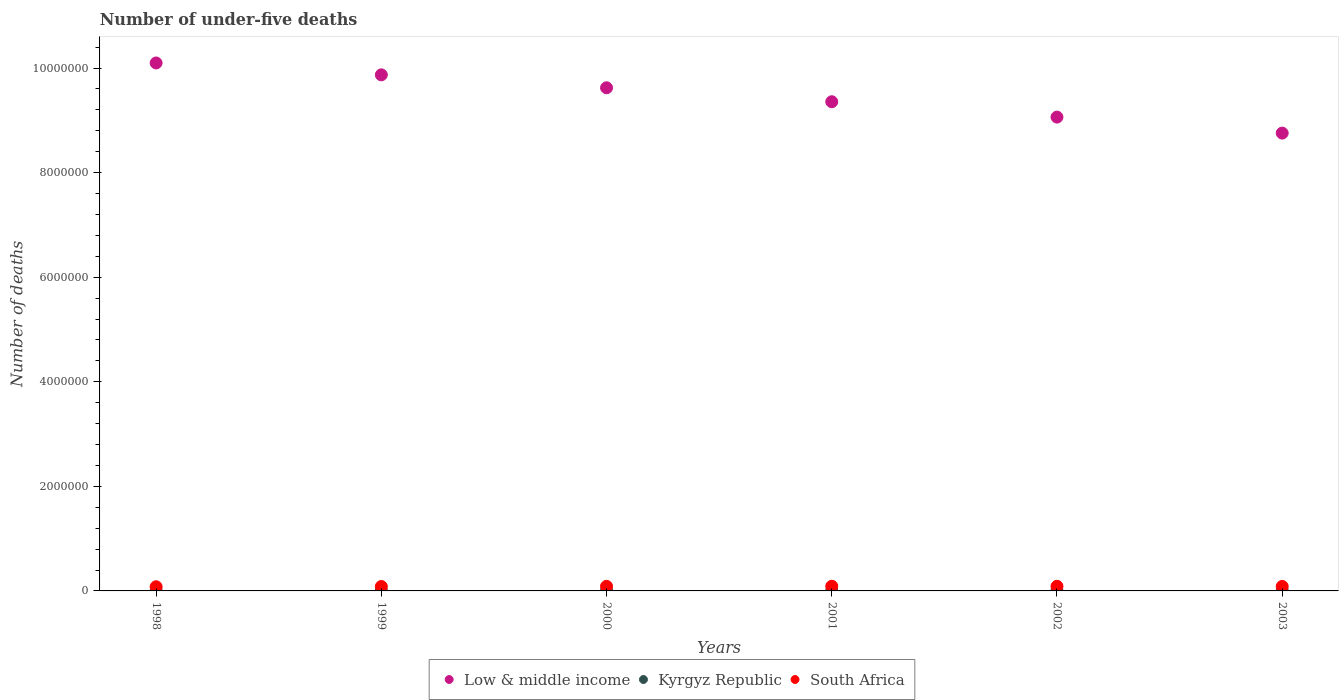How many different coloured dotlines are there?
Offer a very short reply. 3. Is the number of dotlines equal to the number of legend labels?
Your response must be concise. Yes. What is the number of under-five deaths in Low & middle income in 2000?
Ensure brevity in your answer.  9.62e+06. Across all years, what is the maximum number of under-five deaths in Low & middle income?
Offer a terse response. 1.01e+07. Across all years, what is the minimum number of under-five deaths in South Africa?
Make the answer very short. 7.96e+04. What is the total number of under-five deaths in South Africa in the graph?
Provide a short and direct response. 5.15e+05. What is the difference between the number of under-five deaths in South Africa in 1998 and that in 1999?
Ensure brevity in your answer.  -4712. What is the difference between the number of under-five deaths in Kyrgyz Republic in 1998 and the number of under-five deaths in South Africa in 2000?
Your answer should be very brief. -8.18e+04. What is the average number of under-five deaths in Kyrgyz Republic per year?
Your answer should be compact. 5219. In the year 1999, what is the difference between the number of under-five deaths in Kyrgyz Republic and number of under-five deaths in South Africa?
Your answer should be very brief. -7.86e+04. In how many years, is the number of under-five deaths in South Africa greater than 8000000?
Give a very brief answer. 0. What is the ratio of the number of under-five deaths in Low & middle income in 1999 to that in 2000?
Your response must be concise. 1.03. Is the number of under-five deaths in South Africa in 1999 less than that in 2000?
Keep it short and to the point. Yes. What is the difference between the highest and the second highest number of under-five deaths in South Africa?
Provide a succinct answer. 893. What is the difference between the highest and the lowest number of under-five deaths in South Africa?
Your answer should be compact. 9711. In how many years, is the number of under-five deaths in Low & middle income greater than the average number of under-five deaths in Low & middle income taken over all years?
Provide a succinct answer. 3. Is it the case that in every year, the sum of the number of under-five deaths in Kyrgyz Republic and number of under-five deaths in Low & middle income  is greater than the number of under-five deaths in South Africa?
Your answer should be very brief. Yes. How many dotlines are there?
Offer a terse response. 3. What is the difference between two consecutive major ticks on the Y-axis?
Your answer should be very brief. 2.00e+06. Does the graph contain any zero values?
Your answer should be compact. No. Does the graph contain grids?
Give a very brief answer. No. Where does the legend appear in the graph?
Ensure brevity in your answer.  Bottom center. How many legend labels are there?
Provide a succinct answer. 3. How are the legend labels stacked?
Make the answer very short. Horizontal. What is the title of the graph?
Offer a very short reply. Number of under-five deaths. Does "Mexico" appear as one of the legend labels in the graph?
Offer a terse response. No. What is the label or title of the Y-axis?
Provide a short and direct response. Number of deaths. What is the Number of deaths of Low & middle income in 1998?
Provide a succinct answer. 1.01e+07. What is the Number of deaths of Kyrgyz Republic in 1998?
Provide a succinct answer. 6098. What is the Number of deaths in South Africa in 1998?
Provide a succinct answer. 7.96e+04. What is the Number of deaths of Low & middle income in 1999?
Your response must be concise. 9.87e+06. What is the Number of deaths in Kyrgyz Republic in 1999?
Ensure brevity in your answer.  5741. What is the Number of deaths of South Africa in 1999?
Your answer should be compact. 8.43e+04. What is the Number of deaths in Low & middle income in 2000?
Your answer should be very brief. 9.62e+06. What is the Number of deaths of Kyrgyz Republic in 2000?
Make the answer very short. 5380. What is the Number of deaths in South Africa in 2000?
Provide a short and direct response. 8.79e+04. What is the Number of deaths of Low & middle income in 2001?
Give a very brief answer. 9.36e+06. What is the Number of deaths in Kyrgyz Republic in 2001?
Keep it short and to the point. 5021. What is the Number of deaths in South Africa in 2001?
Make the answer very short. 8.93e+04. What is the Number of deaths in Low & middle income in 2002?
Offer a terse response. 9.06e+06. What is the Number of deaths in Kyrgyz Republic in 2002?
Your answer should be compact. 4685. What is the Number of deaths in South Africa in 2002?
Your response must be concise. 8.84e+04. What is the Number of deaths in Low & middle income in 2003?
Provide a short and direct response. 8.76e+06. What is the Number of deaths in Kyrgyz Republic in 2003?
Offer a very short reply. 4389. What is the Number of deaths in South Africa in 2003?
Provide a short and direct response. 8.58e+04. Across all years, what is the maximum Number of deaths of Low & middle income?
Keep it short and to the point. 1.01e+07. Across all years, what is the maximum Number of deaths of Kyrgyz Republic?
Make the answer very short. 6098. Across all years, what is the maximum Number of deaths of South Africa?
Your answer should be very brief. 8.93e+04. Across all years, what is the minimum Number of deaths in Low & middle income?
Offer a terse response. 8.76e+06. Across all years, what is the minimum Number of deaths in Kyrgyz Republic?
Offer a very short reply. 4389. Across all years, what is the minimum Number of deaths in South Africa?
Ensure brevity in your answer.  7.96e+04. What is the total Number of deaths of Low & middle income in the graph?
Provide a short and direct response. 5.68e+07. What is the total Number of deaths in Kyrgyz Republic in the graph?
Your response must be concise. 3.13e+04. What is the total Number of deaths of South Africa in the graph?
Offer a terse response. 5.15e+05. What is the difference between the Number of deaths of Low & middle income in 1998 and that in 1999?
Your answer should be very brief. 2.27e+05. What is the difference between the Number of deaths in Kyrgyz Republic in 1998 and that in 1999?
Offer a terse response. 357. What is the difference between the Number of deaths of South Africa in 1998 and that in 1999?
Give a very brief answer. -4712. What is the difference between the Number of deaths of Low & middle income in 1998 and that in 2000?
Give a very brief answer. 4.75e+05. What is the difference between the Number of deaths of Kyrgyz Republic in 1998 and that in 2000?
Your answer should be very brief. 718. What is the difference between the Number of deaths of South Africa in 1998 and that in 2000?
Keep it short and to the point. -8266. What is the difference between the Number of deaths of Low & middle income in 1998 and that in 2001?
Provide a short and direct response. 7.42e+05. What is the difference between the Number of deaths in Kyrgyz Republic in 1998 and that in 2001?
Your answer should be compact. 1077. What is the difference between the Number of deaths of South Africa in 1998 and that in 2001?
Offer a terse response. -9711. What is the difference between the Number of deaths of Low & middle income in 1998 and that in 2002?
Your response must be concise. 1.04e+06. What is the difference between the Number of deaths of Kyrgyz Republic in 1998 and that in 2002?
Make the answer very short. 1413. What is the difference between the Number of deaths in South Africa in 1998 and that in 2002?
Your response must be concise. -8818. What is the difference between the Number of deaths in Low & middle income in 1998 and that in 2003?
Make the answer very short. 1.34e+06. What is the difference between the Number of deaths of Kyrgyz Republic in 1998 and that in 2003?
Keep it short and to the point. 1709. What is the difference between the Number of deaths of South Africa in 1998 and that in 2003?
Ensure brevity in your answer.  -6147. What is the difference between the Number of deaths in Low & middle income in 1999 and that in 2000?
Offer a terse response. 2.48e+05. What is the difference between the Number of deaths of Kyrgyz Republic in 1999 and that in 2000?
Give a very brief answer. 361. What is the difference between the Number of deaths in South Africa in 1999 and that in 2000?
Keep it short and to the point. -3554. What is the difference between the Number of deaths in Low & middle income in 1999 and that in 2001?
Offer a terse response. 5.14e+05. What is the difference between the Number of deaths of Kyrgyz Republic in 1999 and that in 2001?
Provide a succinct answer. 720. What is the difference between the Number of deaths of South Africa in 1999 and that in 2001?
Give a very brief answer. -4999. What is the difference between the Number of deaths in Low & middle income in 1999 and that in 2002?
Your response must be concise. 8.08e+05. What is the difference between the Number of deaths of Kyrgyz Republic in 1999 and that in 2002?
Your answer should be very brief. 1056. What is the difference between the Number of deaths in South Africa in 1999 and that in 2002?
Provide a succinct answer. -4106. What is the difference between the Number of deaths of Low & middle income in 1999 and that in 2003?
Your answer should be very brief. 1.11e+06. What is the difference between the Number of deaths in Kyrgyz Republic in 1999 and that in 2003?
Your response must be concise. 1352. What is the difference between the Number of deaths in South Africa in 1999 and that in 2003?
Provide a succinct answer. -1435. What is the difference between the Number of deaths of Low & middle income in 2000 and that in 2001?
Make the answer very short. 2.67e+05. What is the difference between the Number of deaths in Kyrgyz Republic in 2000 and that in 2001?
Your answer should be very brief. 359. What is the difference between the Number of deaths of South Africa in 2000 and that in 2001?
Keep it short and to the point. -1445. What is the difference between the Number of deaths in Low & middle income in 2000 and that in 2002?
Offer a very short reply. 5.61e+05. What is the difference between the Number of deaths of Kyrgyz Republic in 2000 and that in 2002?
Make the answer very short. 695. What is the difference between the Number of deaths of South Africa in 2000 and that in 2002?
Provide a succinct answer. -552. What is the difference between the Number of deaths in Low & middle income in 2000 and that in 2003?
Your answer should be compact. 8.67e+05. What is the difference between the Number of deaths in Kyrgyz Republic in 2000 and that in 2003?
Offer a very short reply. 991. What is the difference between the Number of deaths of South Africa in 2000 and that in 2003?
Offer a very short reply. 2119. What is the difference between the Number of deaths in Low & middle income in 2001 and that in 2002?
Give a very brief answer. 2.94e+05. What is the difference between the Number of deaths in Kyrgyz Republic in 2001 and that in 2002?
Provide a short and direct response. 336. What is the difference between the Number of deaths of South Africa in 2001 and that in 2002?
Make the answer very short. 893. What is the difference between the Number of deaths of Low & middle income in 2001 and that in 2003?
Offer a very short reply. 6.00e+05. What is the difference between the Number of deaths in Kyrgyz Republic in 2001 and that in 2003?
Provide a short and direct response. 632. What is the difference between the Number of deaths in South Africa in 2001 and that in 2003?
Give a very brief answer. 3564. What is the difference between the Number of deaths of Low & middle income in 2002 and that in 2003?
Provide a succinct answer. 3.06e+05. What is the difference between the Number of deaths of Kyrgyz Republic in 2002 and that in 2003?
Ensure brevity in your answer.  296. What is the difference between the Number of deaths in South Africa in 2002 and that in 2003?
Give a very brief answer. 2671. What is the difference between the Number of deaths in Low & middle income in 1998 and the Number of deaths in Kyrgyz Republic in 1999?
Your response must be concise. 1.01e+07. What is the difference between the Number of deaths in Low & middle income in 1998 and the Number of deaths in South Africa in 1999?
Provide a short and direct response. 1.00e+07. What is the difference between the Number of deaths of Kyrgyz Republic in 1998 and the Number of deaths of South Africa in 1999?
Provide a succinct answer. -7.82e+04. What is the difference between the Number of deaths of Low & middle income in 1998 and the Number of deaths of Kyrgyz Republic in 2000?
Your response must be concise. 1.01e+07. What is the difference between the Number of deaths of Low & middle income in 1998 and the Number of deaths of South Africa in 2000?
Give a very brief answer. 1.00e+07. What is the difference between the Number of deaths of Kyrgyz Republic in 1998 and the Number of deaths of South Africa in 2000?
Keep it short and to the point. -8.18e+04. What is the difference between the Number of deaths in Low & middle income in 1998 and the Number of deaths in Kyrgyz Republic in 2001?
Offer a terse response. 1.01e+07. What is the difference between the Number of deaths in Low & middle income in 1998 and the Number of deaths in South Africa in 2001?
Offer a terse response. 1.00e+07. What is the difference between the Number of deaths in Kyrgyz Republic in 1998 and the Number of deaths in South Africa in 2001?
Your answer should be very brief. -8.32e+04. What is the difference between the Number of deaths of Low & middle income in 1998 and the Number of deaths of Kyrgyz Republic in 2002?
Offer a very short reply. 1.01e+07. What is the difference between the Number of deaths in Low & middle income in 1998 and the Number of deaths in South Africa in 2002?
Provide a short and direct response. 1.00e+07. What is the difference between the Number of deaths in Kyrgyz Republic in 1998 and the Number of deaths in South Africa in 2002?
Offer a terse response. -8.23e+04. What is the difference between the Number of deaths of Low & middle income in 1998 and the Number of deaths of Kyrgyz Republic in 2003?
Your response must be concise. 1.01e+07. What is the difference between the Number of deaths in Low & middle income in 1998 and the Number of deaths in South Africa in 2003?
Provide a short and direct response. 1.00e+07. What is the difference between the Number of deaths of Kyrgyz Republic in 1998 and the Number of deaths of South Africa in 2003?
Ensure brevity in your answer.  -7.97e+04. What is the difference between the Number of deaths in Low & middle income in 1999 and the Number of deaths in Kyrgyz Republic in 2000?
Your answer should be compact. 9.87e+06. What is the difference between the Number of deaths of Low & middle income in 1999 and the Number of deaths of South Africa in 2000?
Make the answer very short. 9.78e+06. What is the difference between the Number of deaths in Kyrgyz Republic in 1999 and the Number of deaths in South Africa in 2000?
Make the answer very short. -8.21e+04. What is the difference between the Number of deaths in Low & middle income in 1999 and the Number of deaths in Kyrgyz Republic in 2001?
Provide a succinct answer. 9.87e+06. What is the difference between the Number of deaths in Low & middle income in 1999 and the Number of deaths in South Africa in 2001?
Ensure brevity in your answer.  9.78e+06. What is the difference between the Number of deaths of Kyrgyz Republic in 1999 and the Number of deaths of South Africa in 2001?
Give a very brief answer. -8.36e+04. What is the difference between the Number of deaths in Low & middle income in 1999 and the Number of deaths in Kyrgyz Republic in 2002?
Provide a succinct answer. 9.87e+06. What is the difference between the Number of deaths in Low & middle income in 1999 and the Number of deaths in South Africa in 2002?
Keep it short and to the point. 9.78e+06. What is the difference between the Number of deaths in Kyrgyz Republic in 1999 and the Number of deaths in South Africa in 2002?
Offer a very short reply. -8.27e+04. What is the difference between the Number of deaths in Low & middle income in 1999 and the Number of deaths in Kyrgyz Republic in 2003?
Your answer should be compact. 9.87e+06. What is the difference between the Number of deaths in Low & middle income in 1999 and the Number of deaths in South Africa in 2003?
Your answer should be compact. 9.78e+06. What is the difference between the Number of deaths of Kyrgyz Republic in 1999 and the Number of deaths of South Africa in 2003?
Give a very brief answer. -8.00e+04. What is the difference between the Number of deaths of Low & middle income in 2000 and the Number of deaths of Kyrgyz Republic in 2001?
Your answer should be compact. 9.62e+06. What is the difference between the Number of deaths in Low & middle income in 2000 and the Number of deaths in South Africa in 2001?
Ensure brevity in your answer.  9.53e+06. What is the difference between the Number of deaths of Kyrgyz Republic in 2000 and the Number of deaths of South Africa in 2001?
Your answer should be compact. -8.39e+04. What is the difference between the Number of deaths in Low & middle income in 2000 and the Number of deaths in Kyrgyz Republic in 2002?
Your answer should be compact. 9.62e+06. What is the difference between the Number of deaths of Low & middle income in 2000 and the Number of deaths of South Africa in 2002?
Give a very brief answer. 9.53e+06. What is the difference between the Number of deaths of Kyrgyz Republic in 2000 and the Number of deaths of South Africa in 2002?
Provide a succinct answer. -8.30e+04. What is the difference between the Number of deaths of Low & middle income in 2000 and the Number of deaths of Kyrgyz Republic in 2003?
Offer a terse response. 9.62e+06. What is the difference between the Number of deaths in Low & middle income in 2000 and the Number of deaths in South Africa in 2003?
Offer a terse response. 9.54e+06. What is the difference between the Number of deaths of Kyrgyz Republic in 2000 and the Number of deaths of South Africa in 2003?
Offer a very short reply. -8.04e+04. What is the difference between the Number of deaths in Low & middle income in 2001 and the Number of deaths in Kyrgyz Republic in 2002?
Provide a short and direct response. 9.35e+06. What is the difference between the Number of deaths in Low & middle income in 2001 and the Number of deaths in South Africa in 2002?
Provide a short and direct response. 9.27e+06. What is the difference between the Number of deaths in Kyrgyz Republic in 2001 and the Number of deaths in South Africa in 2002?
Make the answer very short. -8.34e+04. What is the difference between the Number of deaths of Low & middle income in 2001 and the Number of deaths of Kyrgyz Republic in 2003?
Your answer should be very brief. 9.35e+06. What is the difference between the Number of deaths in Low & middle income in 2001 and the Number of deaths in South Africa in 2003?
Your answer should be compact. 9.27e+06. What is the difference between the Number of deaths of Kyrgyz Republic in 2001 and the Number of deaths of South Africa in 2003?
Ensure brevity in your answer.  -8.07e+04. What is the difference between the Number of deaths of Low & middle income in 2002 and the Number of deaths of Kyrgyz Republic in 2003?
Ensure brevity in your answer.  9.06e+06. What is the difference between the Number of deaths of Low & middle income in 2002 and the Number of deaths of South Africa in 2003?
Give a very brief answer. 8.98e+06. What is the difference between the Number of deaths of Kyrgyz Republic in 2002 and the Number of deaths of South Africa in 2003?
Your answer should be very brief. -8.11e+04. What is the average Number of deaths in Low & middle income per year?
Provide a succinct answer. 9.46e+06. What is the average Number of deaths in Kyrgyz Republic per year?
Your answer should be compact. 5219. What is the average Number of deaths in South Africa per year?
Your answer should be compact. 8.59e+04. In the year 1998, what is the difference between the Number of deaths in Low & middle income and Number of deaths in Kyrgyz Republic?
Keep it short and to the point. 1.01e+07. In the year 1998, what is the difference between the Number of deaths in Low & middle income and Number of deaths in South Africa?
Your response must be concise. 1.00e+07. In the year 1998, what is the difference between the Number of deaths in Kyrgyz Republic and Number of deaths in South Africa?
Make the answer very short. -7.35e+04. In the year 1999, what is the difference between the Number of deaths of Low & middle income and Number of deaths of Kyrgyz Republic?
Offer a terse response. 9.86e+06. In the year 1999, what is the difference between the Number of deaths of Low & middle income and Number of deaths of South Africa?
Provide a short and direct response. 9.79e+06. In the year 1999, what is the difference between the Number of deaths in Kyrgyz Republic and Number of deaths in South Africa?
Offer a very short reply. -7.86e+04. In the year 2000, what is the difference between the Number of deaths of Low & middle income and Number of deaths of Kyrgyz Republic?
Your answer should be very brief. 9.62e+06. In the year 2000, what is the difference between the Number of deaths in Low & middle income and Number of deaths in South Africa?
Your response must be concise. 9.54e+06. In the year 2000, what is the difference between the Number of deaths of Kyrgyz Republic and Number of deaths of South Africa?
Make the answer very short. -8.25e+04. In the year 2001, what is the difference between the Number of deaths of Low & middle income and Number of deaths of Kyrgyz Republic?
Keep it short and to the point. 9.35e+06. In the year 2001, what is the difference between the Number of deaths of Low & middle income and Number of deaths of South Africa?
Make the answer very short. 9.27e+06. In the year 2001, what is the difference between the Number of deaths in Kyrgyz Republic and Number of deaths in South Africa?
Provide a short and direct response. -8.43e+04. In the year 2002, what is the difference between the Number of deaths of Low & middle income and Number of deaths of Kyrgyz Republic?
Make the answer very short. 9.06e+06. In the year 2002, what is the difference between the Number of deaths of Low & middle income and Number of deaths of South Africa?
Your response must be concise. 8.97e+06. In the year 2002, what is the difference between the Number of deaths in Kyrgyz Republic and Number of deaths in South Africa?
Offer a very short reply. -8.37e+04. In the year 2003, what is the difference between the Number of deaths of Low & middle income and Number of deaths of Kyrgyz Republic?
Provide a short and direct response. 8.75e+06. In the year 2003, what is the difference between the Number of deaths of Low & middle income and Number of deaths of South Africa?
Keep it short and to the point. 8.67e+06. In the year 2003, what is the difference between the Number of deaths in Kyrgyz Republic and Number of deaths in South Africa?
Keep it short and to the point. -8.14e+04. What is the ratio of the Number of deaths of Low & middle income in 1998 to that in 1999?
Offer a very short reply. 1.02. What is the ratio of the Number of deaths in Kyrgyz Republic in 1998 to that in 1999?
Provide a short and direct response. 1.06. What is the ratio of the Number of deaths in South Africa in 1998 to that in 1999?
Your answer should be compact. 0.94. What is the ratio of the Number of deaths of Low & middle income in 1998 to that in 2000?
Make the answer very short. 1.05. What is the ratio of the Number of deaths in Kyrgyz Republic in 1998 to that in 2000?
Provide a short and direct response. 1.13. What is the ratio of the Number of deaths in South Africa in 1998 to that in 2000?
Ensure brevity in your answer.  0.91. What is the ratio of the Number of deaths in Low & middle income in 1998 to that in 2001?
Provide a succinct answer. 1.08. What is the ratio of the Number of deaths in Kyrgyz Republic in 1998 to that in 2001?
Ensure brevity in your answer.  1.21. What is the ratio of the Number of deaths in South Africa in 1998 to that in 2001?
Your answer should be very brief. 0.89. What is the ratio of the Number of deaths in Low & middle income in 1998 to that in 2002?
Give a very brief answer. 1.11. What is the ratio of the Number of deaths of Kyrgyz Republic in 1998 to that in 2002?
Your response must be concise. 1.3. What is the ratio of the Number of deaths of South Africa in 1998 to that in 2002?
Your answer should be very brief. 0.9. What is the ratio of the Number of deaths in Low & middle income in 1998 to that in 2003?
Offer a very short reply. 1.15. What is the ratio of the Number of deaths in Kyrgyz Republic in 1998 to that in 2003?
Keep it short and to the point. 1.39. What is the ratio of the Number of deaths in South Africa in 1998 to that in 2003?
Give a very brief answer. 0.93. What is the ratio of the Number of deaths of Low & middle income in 1999 to that in 2000?
Your answer should be compact. 1.03. What is the ratio of the Number of deaths of Kyrgyz Republic in 1999 to that in 2000?
Your answer should be compact. 1.07. What is the ratio of the Number of deaths of South Africa in 1999 to that in 2000?
Provide a succinct answer. 0.96. What is the ratio of the Number of deaths in Low & middle income in 1999 to that in 2001?
Your answer should be very brief. 1.05. What is the ratio of the Number of deaths in Kyrgyz Republic in 1999 to that in 2001?
Ensure brevity in your answer.  1.14. What is the ratio of the Number of deaths of South Africa in 1999 to that in 2001?
Keep it short and to the point. 0.94. What is the ratio of the Number of deaths of Low & middle income in 1999 to that in 2002?
Give a very brief answer. 1.09. What is the ratio of the Number of deaths in Kyrgyz Republic in 1999 to that in 2002?
Keep it short and to the point. 1.23. What is the ratio of the Number of deaths in South Africa in 1999 to that in 2002?
Ensure brevity in your answer.  0.95. What is the ratio of the Number of deaths in Low & middle income in 1999 to that in 2003?
Offer a very short reply. 1.13. What is the ratio of the Number of deaths in Kyrgyz Republic in 1999 to that in 2003?
Make the answer very short. 1.31. What is the ratio of the Number of deaths in South Africa in 1999 to that in 2003?
Ensure brevity in your answer.  0.98. What is the ratio of the Number of deaths of Low & middle income in 2000 to that in 2001?
Your answer should be compact. 1.03. What is the ratio of the Number of deaths of Kyrgyz Republic in 2000 to that in 2001?
Your response must be concise. 1.07. What is the ratio of the Number of deaths of South Africa in 2000 to that in 2001?
Make the answer very short. 0.98. What is the ratio of the Number of deaths of Low & middle income in 2000 to that in 2002?
Offer a very short reply. 1.06. What is the ratio of the Number of deaths in Kyrgyz Republic in 2000 to that in 2002?
Provide a succinct answer. 1.15. What is the ratio of the Number of deaths of Low & middle income in 2000 to that in 2003?
Ensure brevity in your answer.  1.1. What is the ratio of the Number of deaths in Kyrgyz Republic in 2000 to that in 2003?
Provide a short and direct response. 1.23. What is the ratio of the Number of deaths in South Africa in 2000 to that in 2003?
Provide a short and direct response. 1.02. What is the ratio of the Number of deaths of Low & middle income in 2001 to that in 2002?
Your answer should be very brief. 1.03. What is the ratio of the Number of deaths in Kyrgyz Republic in 2001 to that in 2002?
Give a very brief answer. 1.07. What is the ratio of the Number of deaths of South Africa in 2001 to that in 2002?
Offer a terse response. 1.01. What is the ratio of the Number of deaths in Low & middle income in 2001 to that in 2003?
Keep it short and to the point. 1.07. What is the ratio of the Number of deaths of Kyrgyz Republic in 2001 to that in 2003?
Ensure brevity in your answer.  1.14. What is the ratio of the Number of deaths in South Africa in 2001 to that in 2003?
Your answer should be compact. 1.04. What is the ratio of the Number of deaths of Low & middle income in 2002 to that in 2003?
Your response must be concise. 1.03. What is the ratio of the Number of deaths of Kyrgyz Republic in 2002 to that in 2003?
Keep it short and to the point. 1.07. What is the ratio of the Number of deaths of South Africa in 2002 to that in 2003?
Give a very brief answer. 1.03. What is the difference between the highest and the second highest Number of deaths of Low & middle income?
Make the answer very short. 2.27e+05. What is the difference between the highest and the second highest Number of deaths of Kyrgyz Republic?
Provide a short and direct response. 357. What is the difference between the highest and the second highest Number of deaths of South Africa?
Provide a short and direct response. 893. What is the difference between the highest and the lowest Number of deaths of Low & middle income?
Offer a terse response. 1.34e+06. What is the difference between the highest and the lowest Number of deaths in Kyrgyz Republic?
Your answer should be very brief. 1709. What is the difference between the highest and the lowest Number of deaths in South Africa?
Offer a terse response. 9711. 